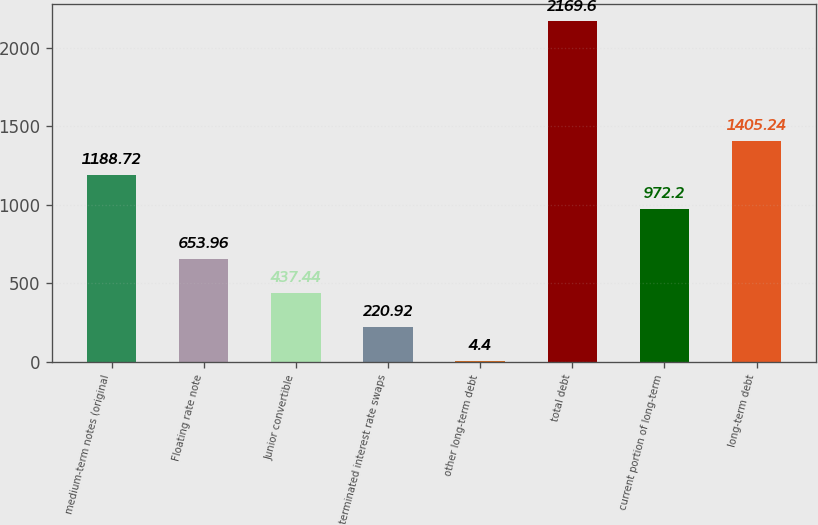<chart> <loc_0><loc_0><loc_500><loc_500><bar_chart><fcel>medium-term notes (original<fcel>Floating rate note<fcel>Junior convertible<fcel>terminated interest rate swaps<fcel>other long-term debt<fcel>total debt<fcel>current portion of long-term<fcel>long-term debt<nl><fcel>1188.72<fcel>653.96<fcel>437.44<fcel>220.92<fcel>4.4<fcel>2169.6<fcel>972.2<fcel>1405.24<nl></chart> 